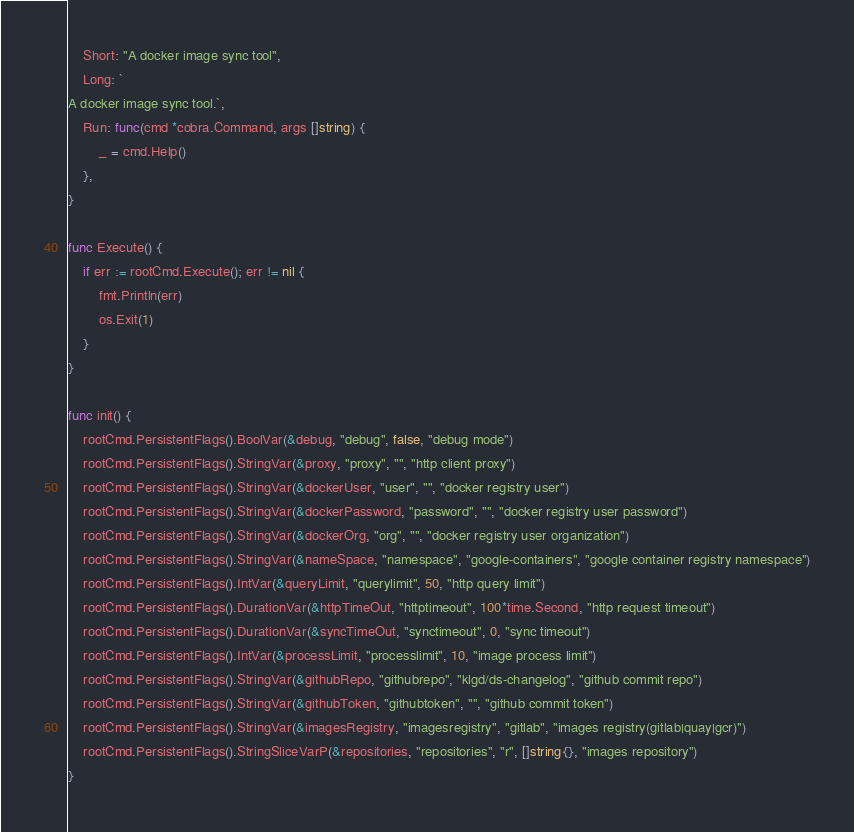Convert code to text. <code><loc_0><loc_0><loc_500><loc_500><_Go_>	Short: "A docker image sync tool",
	Long: `
A docker image sync tool.`,
	Run: func(cmd *cobra.Command, args []string) {
		_ = cmd.Help()
	},
}

func Execute() {
	if err := rootCmd.Execute(); err != nil {
		fmt.Println(err)
		os.Exit(1)
	}
}

func init() {
	rootCmd.PersistentFlags().BoolVar(&debug, "debug", false, "debug mode")
	rootCmd.PersistentFlags().StringVar(&proxy, "proxy", "", "http client proxy")
	rootCmd.PersistentFlags().StringVar(&dockerUser, "user", "", "docker registry user")
	rootCmd.PersistentFlags().StringVar(&dockerPassword, "password", "", "docker registry user password")
	rootCmd.PersistentFlags().StringVar(&dockerOrg, "org", "", "docker registry user organization")
	rootCmd.PersistentFlags().StringVar(&nameSpace, "namespace", "google-containers", "google container registry namespace")
	rootCmd.PersistentFlags().IntVar(&queryLimit, "querylimit", 50, "http query limit")
	rootCmd.PersistentFlags().DurationVar(&httpTimeOut, "httptimeout", 100*time.Second, "http request timeout")
	rootCmd.PersistentFlags().DurationVar(&syncTimeOut, "synctimeout", 0, "sync timeout")
	rootCmd.PersistentFlags().IntVar(&processLimit, "processlimit", 10, "image process limit")
	rootCmd.PersistentFlags().StringVar(&githubRepo, "githubrepo", "klgd/ds-changelog", "github commit repo")
	rootCmd.PersistentFlags().StringVar(&githubToken, "githubtoken", "", "github commit token")
	rootCmd.PersistentFlags().StringVar(&imagesRegistry, "imagesregistry", "gitlab", "images registry(gitlab|quay|gcr)")
	rootCmd.PersistentFlags().StringSliceVarP(&repositories, "repositories", "r", []string{}, "images repository")
}
</code> 